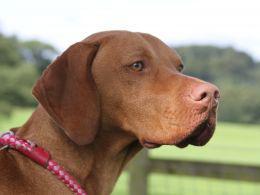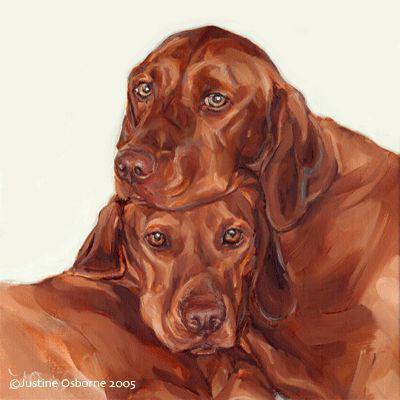The first image is the image on the left, the second image is the image on the right. Considering the images on both sides, is "At least one hound has a red collar around its neck." valid? Answer yes or no. Yes. The first image is the image on the left, the second image is the image on the right. Evaluate the accuracy of this statement regarding the images: "The left image contains one reddish-orange dog wearing a red braided cord around its neck.". Is it true? Answer yes or no. Yes. 